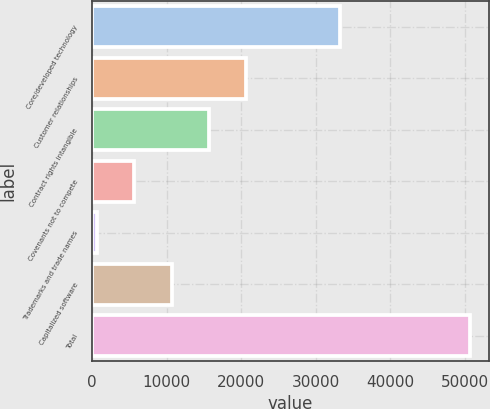<chart> <loc_0><loc_0><loc_500><loc_500><bar_chart><fcel>Core/developed technology<fcel>Customer relationships<fcel>Contract rights intangible<fcel>Covenants not to compete<fcel>Trademarks and trade names<fcel>Capitalized software<fcel>Total<nl><fcel>33232<fcel>20637.6<fcel>15635.7<fcel>5631.9<fcel>630<fcel>10633.8<fcel>50649<nl></chart> 